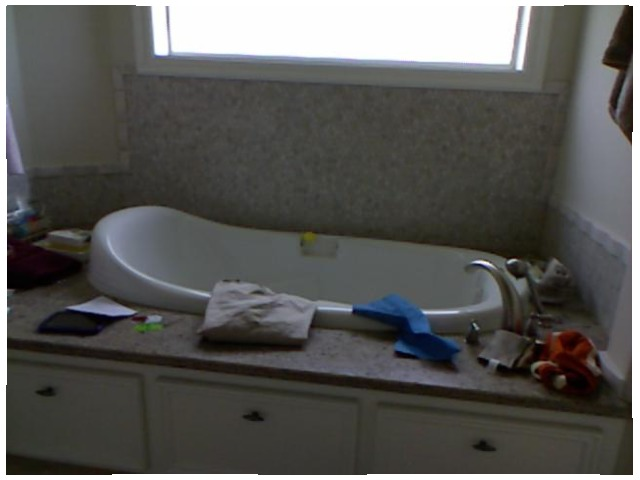<image>
Can you confirm if the bath is in front of the window? Yes. The bath is positioned in front of the window, appearing closer to the camera viewpoint. Is the towel on the tub? Yes. Looking at the image, I can see the towel is positioned on top of the tub, with the tub providing support. Is there a window above the bath tub? Yes. The window is positioned above the bath tub in the vertical space, higher up in the scene. Is the window above the sink? Yes. The window is positioned above the sink in the vertical space, higher up in the scene. 